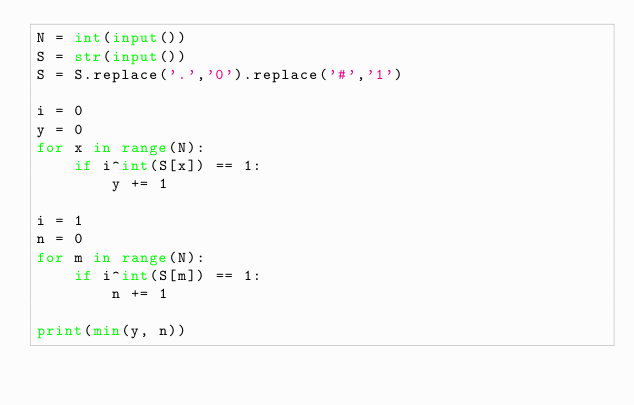Convert code to text. <code><loc_0><loc_0><loc_500><loc_500><_Python_>N = int(input())
S = str(input())
S = S.replace('.','0').replace('#','1')

i = 0
y = 0
for x in range(N):
    if i^int(S[x]) == 1:
        y += 1

i = 1
n = 0
for m in range(N):
    if i^int(S[m]) == 1:
        n += 1

print(min(y, n))</code> 